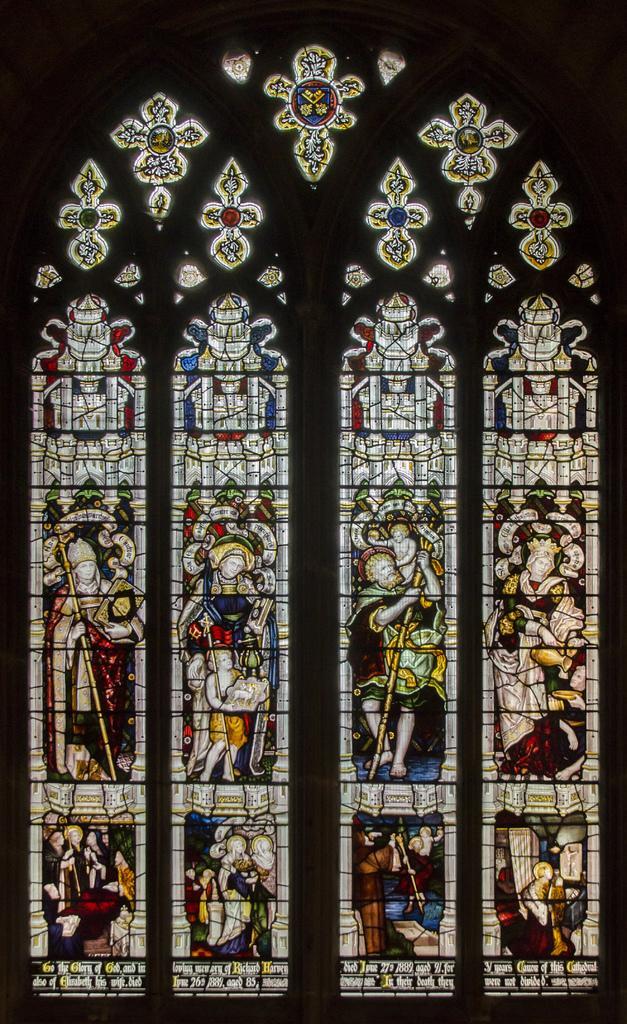In one or two sentences, can you explain what this image depicts? In this picture we can see a window with colorful glass paintings. 